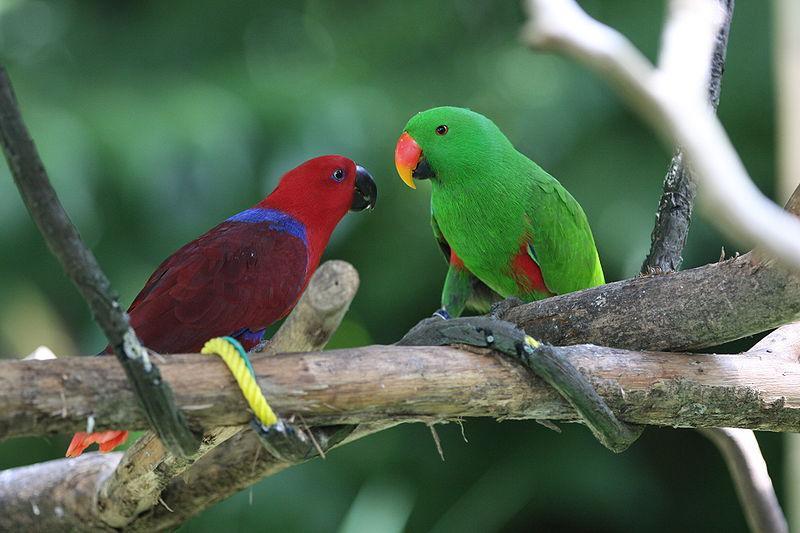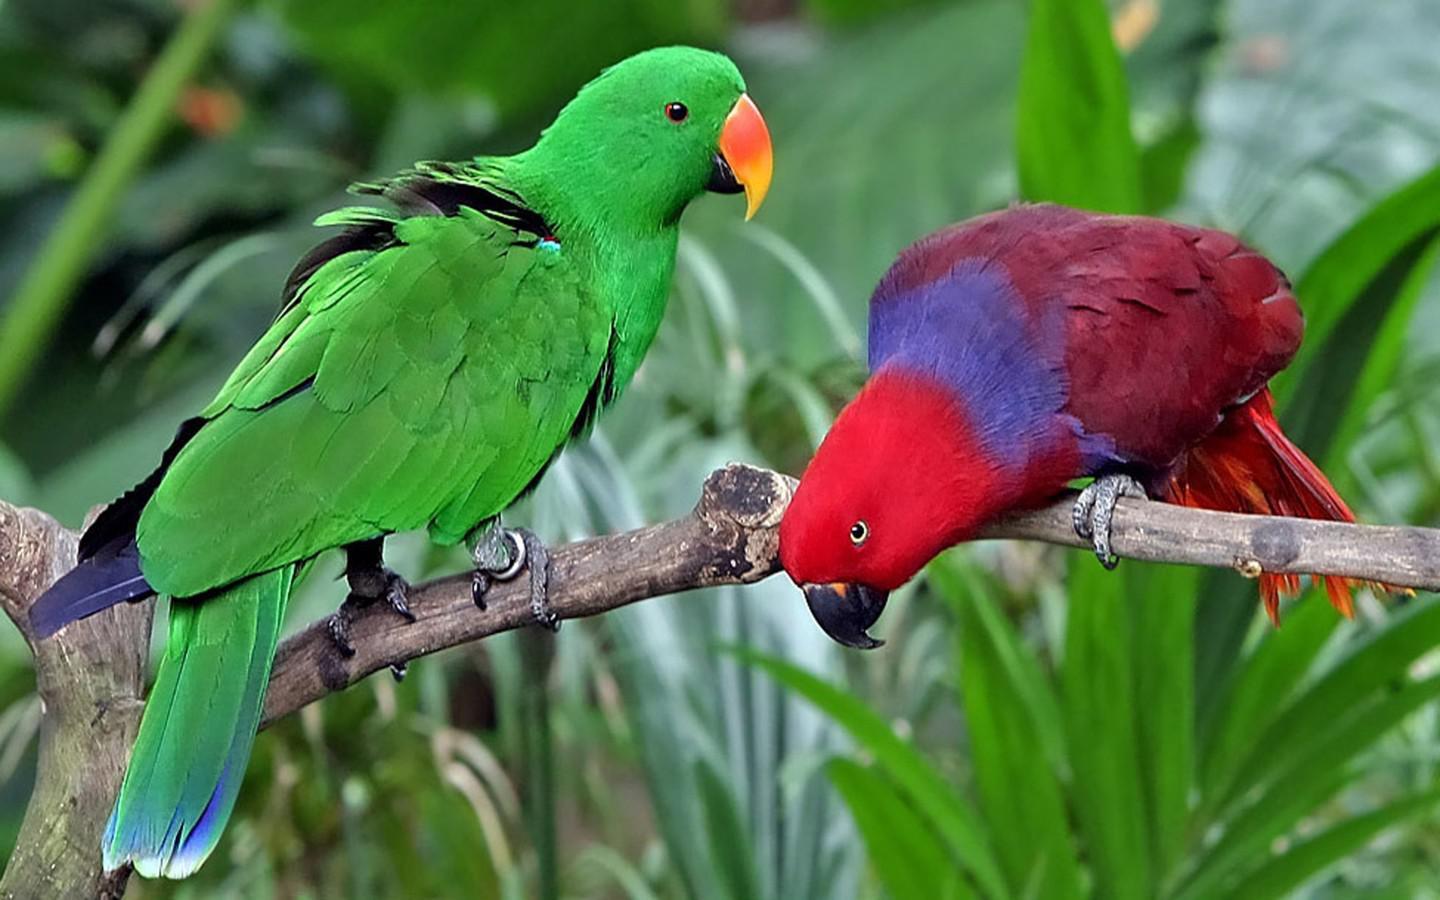The first image is the image on the left, the second image is the image on the right. For the images shown, is this caption "Parrots in the right and left images share the same coloration or colorations." true? Answer yes or no. Yes. The first image is the image on the left, the second image is the image on the right. Given the left and right images, does the statement "There are exactly two birds in the image on the right." hold true? Answer yes or no. Yes. 